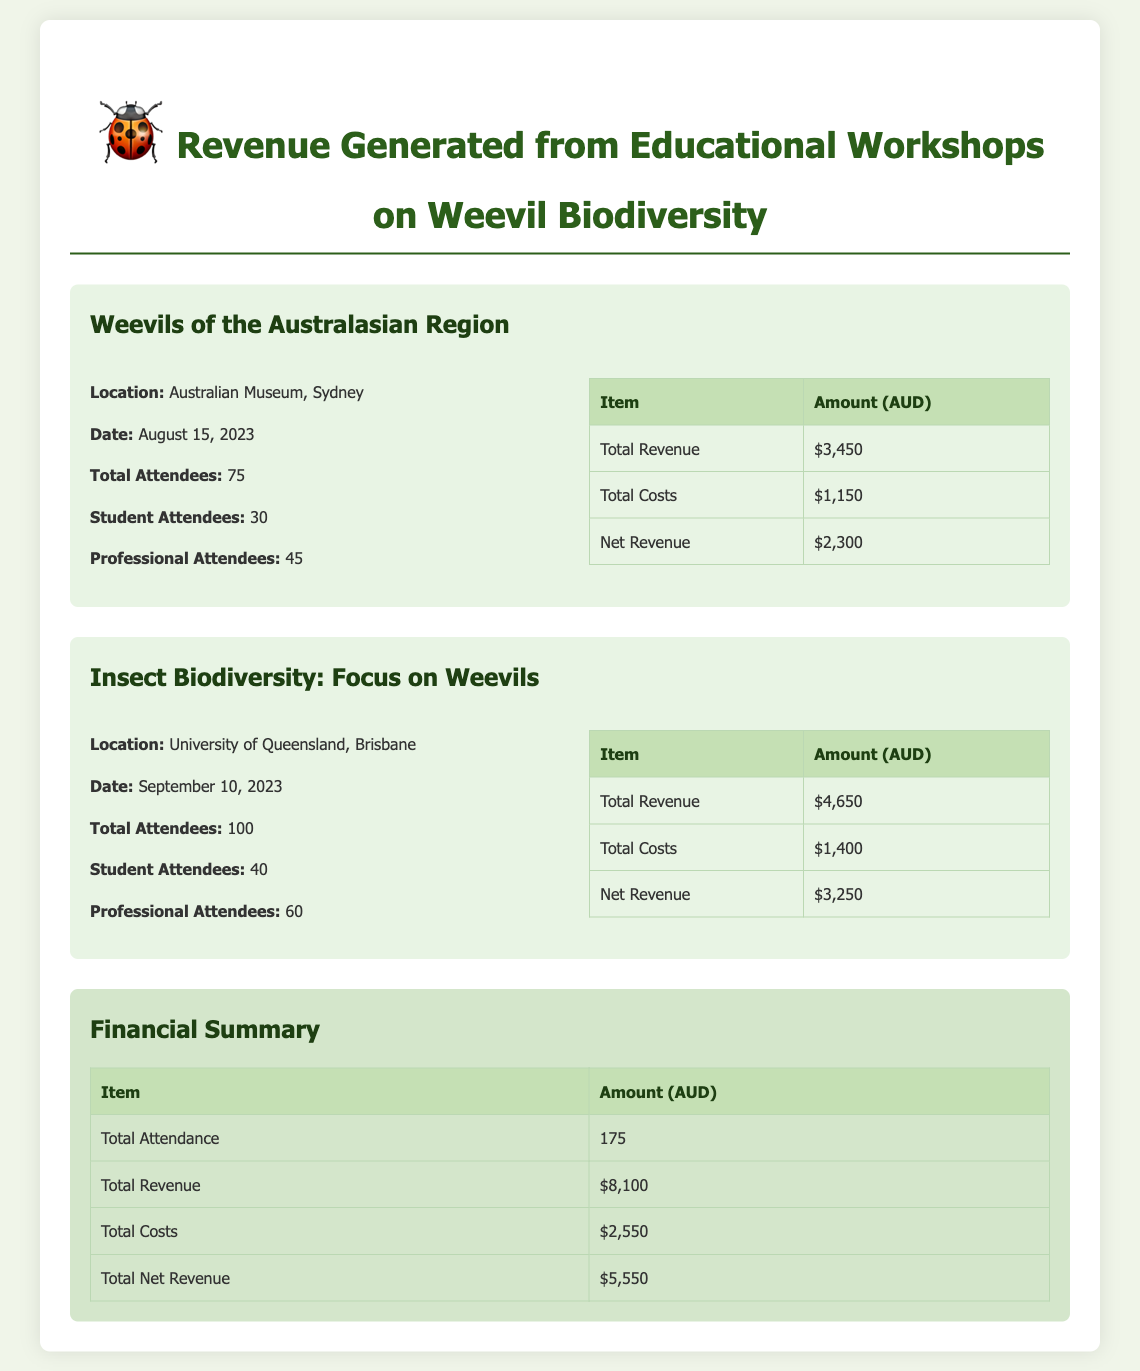What is the location of the first workshop? The document states that the first workshop titled "Weevils of the Australasian Region" was held at the Australian Museum, Sydney.
Answer: Australian Museum, Sydney What is the total attendance for the second workshop? The total number of attendees for the second workshop, "Insect Biodiversity: Focus on Weevils," is given as 100.
Answer: 100 How much was the total revenue generated from both workshops? The total revenue is provided in the summary section as the total of both workshops: $3,450 + $4,650 = $8,100.
Answer: $8,100 What percentage of attendees were students in the first workshop? The first workshop had 30 student attendees out of 75 total attendees, making the percentage (30/75)*100 = 40%.
Answer: 40% What are the total costs incurred for the workshops? The total costs for both workshops are provided in the summary section and calculated as $1,150 + $1,400 = $2,550.
Answer: $2,550 What was the net revenue from the first workshop? The document states that the net revenue for the first workshop is $2,300.
Answer: $2,300 How many professional attendees were at the second workshop? The information states that there were 60 professional attendees at the second workshop.
Answer: 60 What is the date of the first workshop? The date for the "Weevils of the Australasian Region" workshop is listed as August 15, 2023.
Answer: August 15, 2023 What type of document is this? This document is a financial report summarizing the revenue, costs, and attendance statistics from educational workshops on weevil biodiversity.
Answer: Financial report 